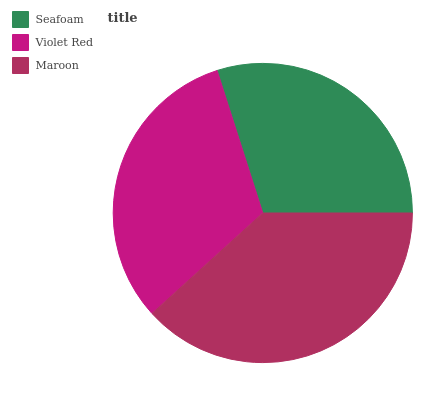Is Seafoam the minimum?
Answer yes or no. Yes. Is Maroon the maximum?
Answer yes or no. Yes. Is Violet Red the minimum?
Answer yes or no. No. Is Violet Red the maximum?
Answer yes or no. No. Is Violet Red greater than Seafoam?
Answer yes or no. Yes. Is Seafoam less than Violet Red?
Answer yes or no. Yes. Is Seafoam greater than Violet Red?
Answer yes or no. No. Is Violet Red less than Seafoam?
Answer yes or no. No. Is Violet Red the high median?
Answer yes or no. Yes. Is Violet Red the low median?
Answer yes or no. Yes. Is Maroon the high median?
Answer yes or no. No. Is Maroon the low median?
Answer yes or no. No. 